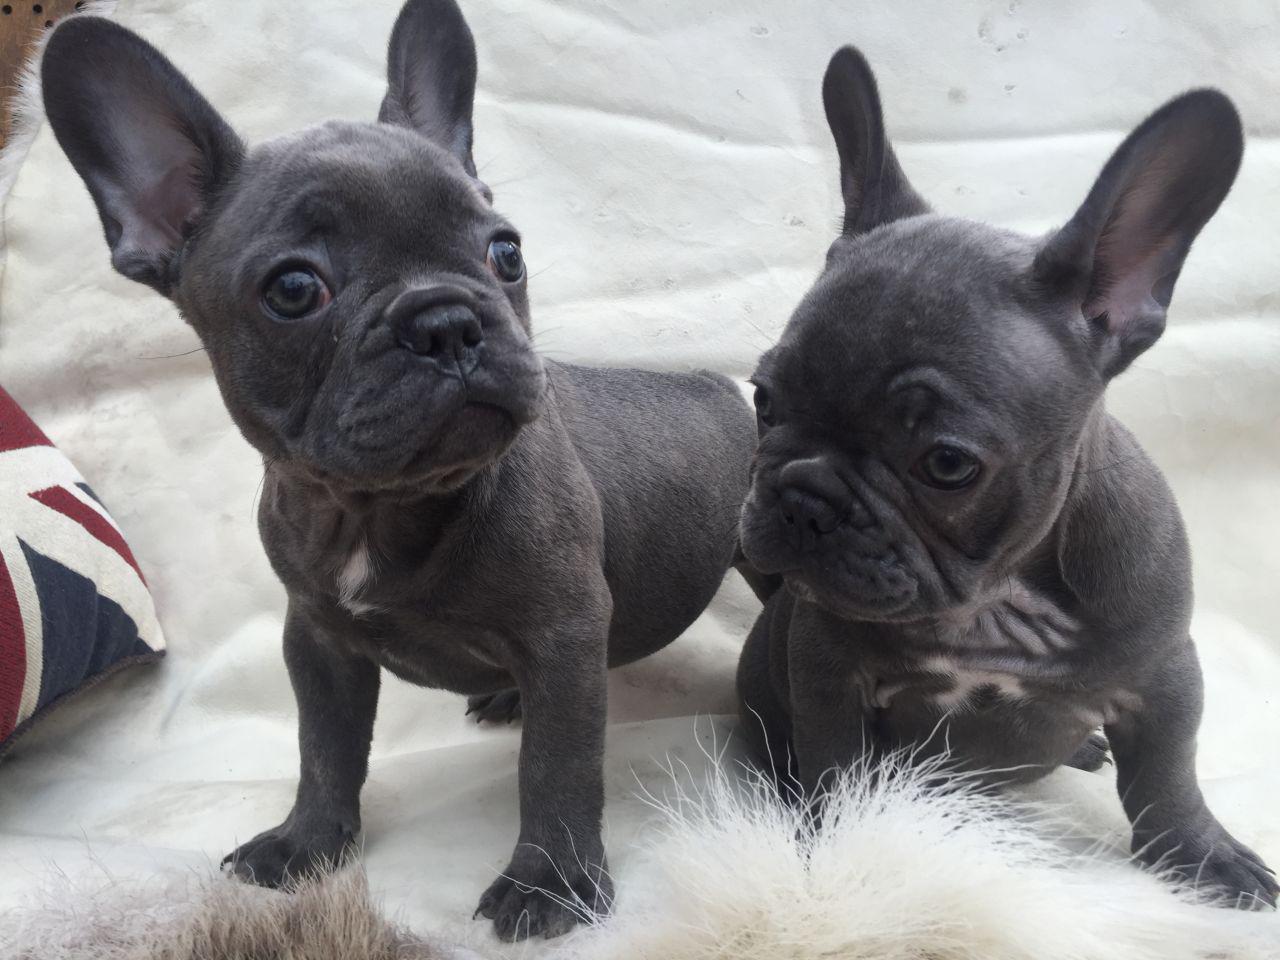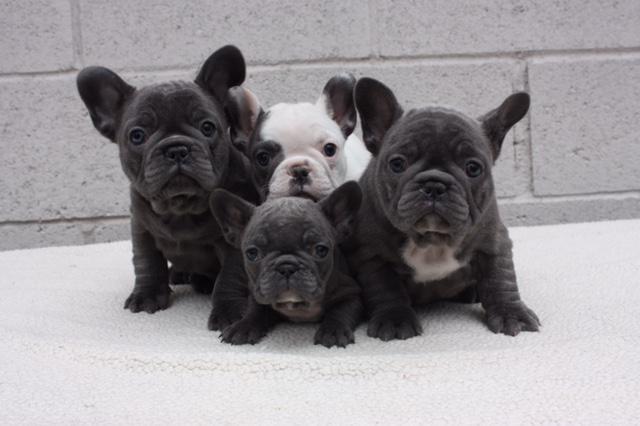The first image is the image on the left, the second image is the image on the right. Assess this claim about the two images: "An image shows a black dog with some type of toy in the side of its mouth.". Correct or not? Answer yes or no. No. The first image is the image on the left, the second image is the image on the right. For the images shown, is this caption "The single dog in each image is indoors." true? Answer yes or no. No. 